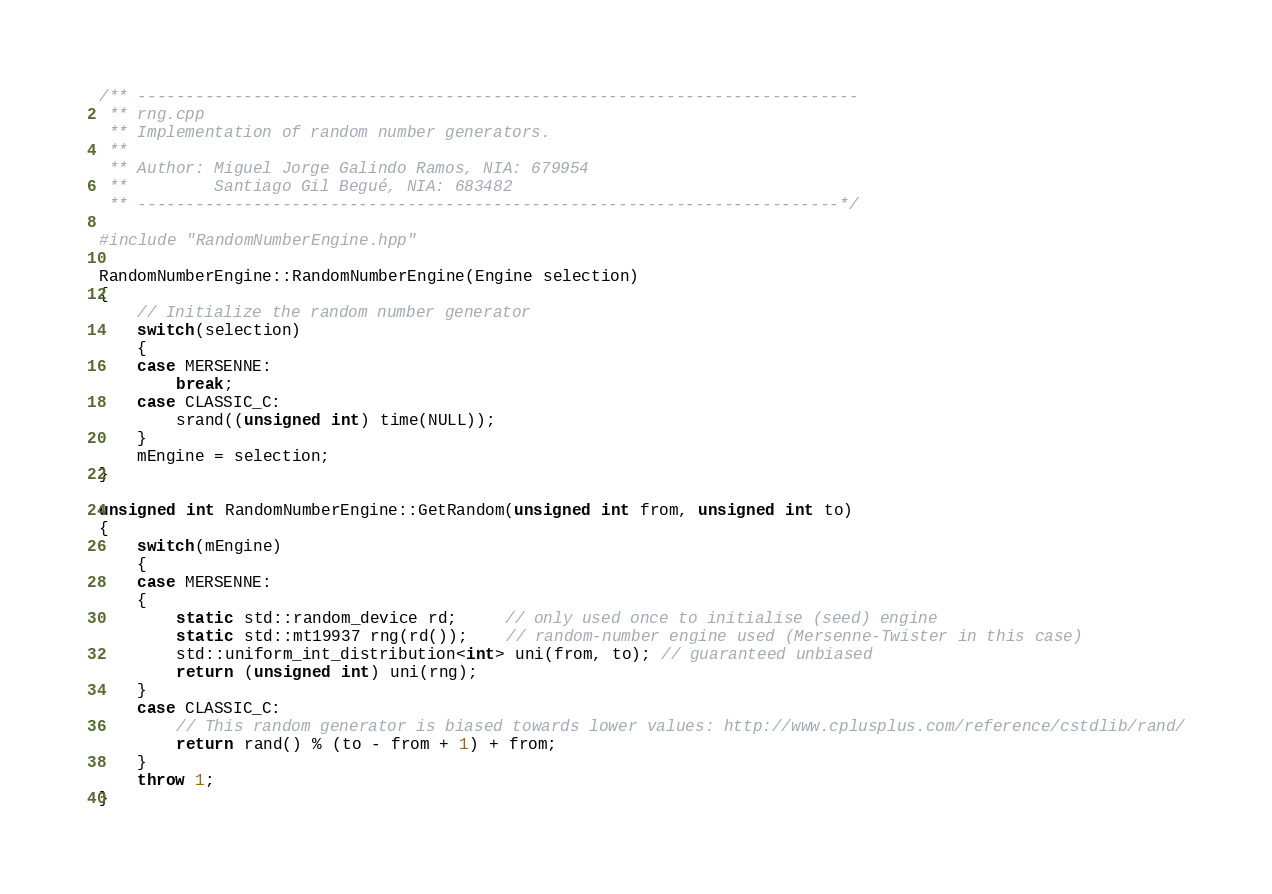Convert code to text. <code><loc_0><loc_0><loc_500><loc_500><_C++_>/** ---------------------------------------------------------------------------
 ** rng.cpp
 ** Implementation of random number generators.
 **
 ** Author: Miguel Jorge Galindo Ramos, NIA: 679954
 **         Santiago Gil Begué, NIA: 683482
 ** -------------------------------------------------------------------------*/

#include "RandomNumberEngine.hpp"

RandomNumberEngine::RandomNumberEngine(Engine selection)
{
    // Initialize the random number generator
    switch(selection)
    {
    case MERSENNE:
        break;
    case CLASSIC_C:
        srand((unsigned int) time(NULL));
    }
    mEngine = selection;
}

unsigned int RandomNumberEngine::GetRandom(unsigned int from, unsigned int to)
{
    switch(mEngine)
    {
    case MERSENNE:
    {
        static std::random_device rd;     // only used once to initialise (seed) engine
        static std::mt19937 rng(rd());    // random-number engine used (Mersenne-Twister in this case)
        std::uniform_int_distribution<int> uni(from, to); // guaranteed unbiased
        return (unsigned int) uni(rng);
    }
    case CLASSIC_C:
        // This random generator is biased towards lower values: http://www.cplusplus.com/reference/cstdlib/rand/
        return rand() % (to - from + 1) + from;
    }
    throw 1;
}
</code> 